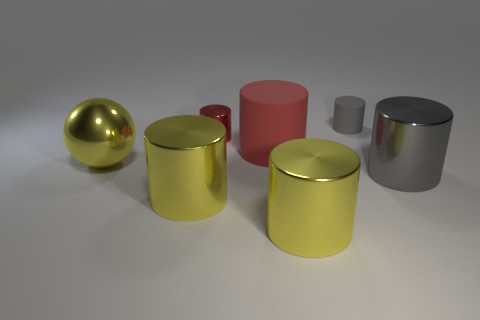Is the color of the tiny shiny object the same as the big rubber cylinder?
Provide a short and direct response. Yes. What number of red metal objects are behind the gray cylinder that is in front of the rubber cylinder that is to the left of the gray rubber thing?
Offer a terse response. 1. What shape is the red thing that is made of the same material as the big gray cylinder?
Provide a succinct answer. Cylinder. There is a gray object that is behind the big metal thing that is behind the gray cylinder in front of the small gray object; what is its material?
Ensure brevity in your answer.  Rubber. How many objects are metal objects that are on the right side of the gray rubber cylinder or big gray objects?
Keep it short and to the point. 1. How many other things are there of the same shape as the tiny gray object?
Provide a succinct answer. 5. Is the number of large cylinders that are on the left side of the large red thing greater than the number of large red spheres?
Offer a terse response. Yes. The other rubber thing that is the same shape as the large red matte thing is what size?
Your answer should be compact. Small. What shape is the red matte object?
Your answer should be compact. Cylinder. What shape is the gray thing that is the same size as the red rubber cylinder?
Your answer should be very brief. Cylinder. 